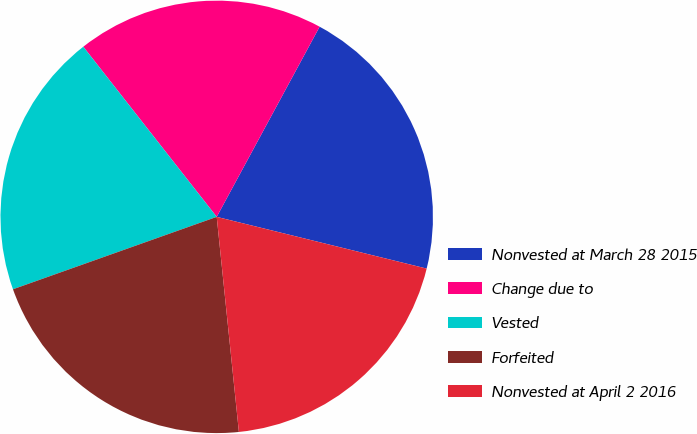<chart> <loc_0><loc_0><loc_500><loc_500><pie_chart><fcel>Nonvested at March 28 2015<fcel>Change due to<fcel>Vested<fcel>Forfeited<fcel>Nonvested at April 2 2016<nl><fcel>20.95%<fcel>18.48%<fcel>19.85%<fcel>21.2%<fcel>19.52%<nl></chart> 